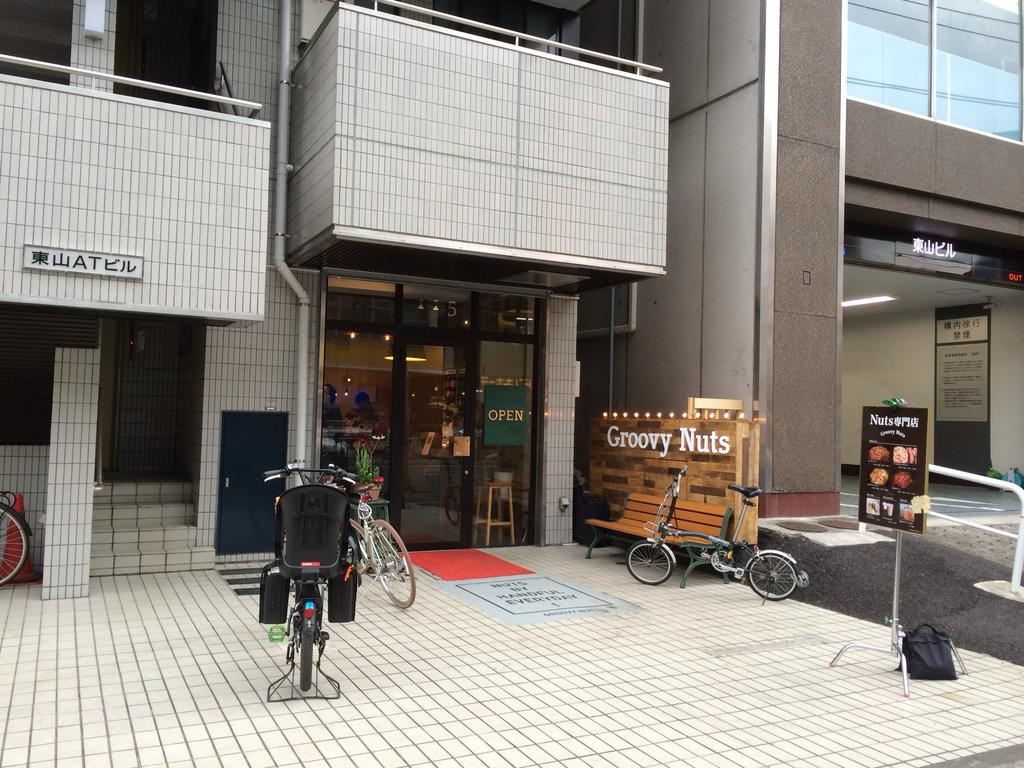What type of structure can be seen in the background of the image? There are buildings in the background of the image. What is the main subject of the image? The main subject of the image is a store. Where is the store located in relation to the building? The store is located at the bottom of a building. What can be seen in front of the store? There are bicycles and a bench in front of the store. What is present on the right side of the image? There is a banner on the right side of the image. Can you see any spies hiding behind the bicycles in the image? There are no spies visible in the image, and it does not mention any hidden objects or people. 